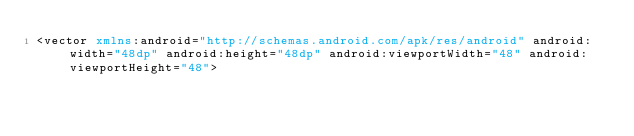Convert code to text. <code><loc_0><loc_0><loc_500><loc_500><_XML_><vector xmlns:android="http://schemas.android.com/apk/res/android" android:width="48dp" android:height="48dp" android:viewportWidth="48" android:viewportHeight="48"></code> 